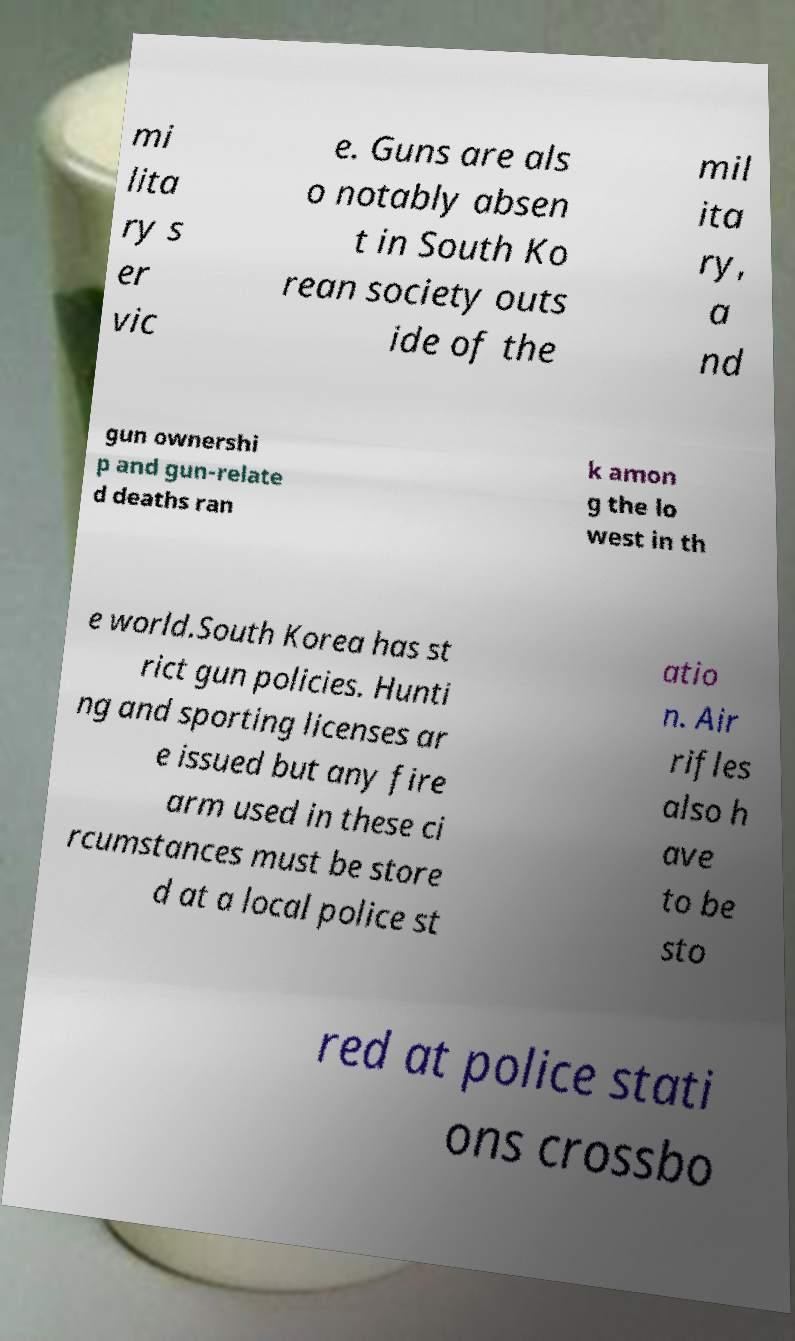Can you read and provide the text displayed in the image?This photo seems to have some interesting text. Can you extract and type it out for me? mi lita ry s er vic e. Guns are als o notably absen t in South Ko rean society outs ide of the mil ita ry, a nd gun ownershi p and gun-relate d deaths ran k amon g the lo west in th e world.South Korea has st rict gun policies. Hunti ng and sporting licenses ar e issued but any fire arm used in these ci rcumstances must be store d at a local police st atio n. Air rifles also h ave to be sto red at police stati ons crossbo 